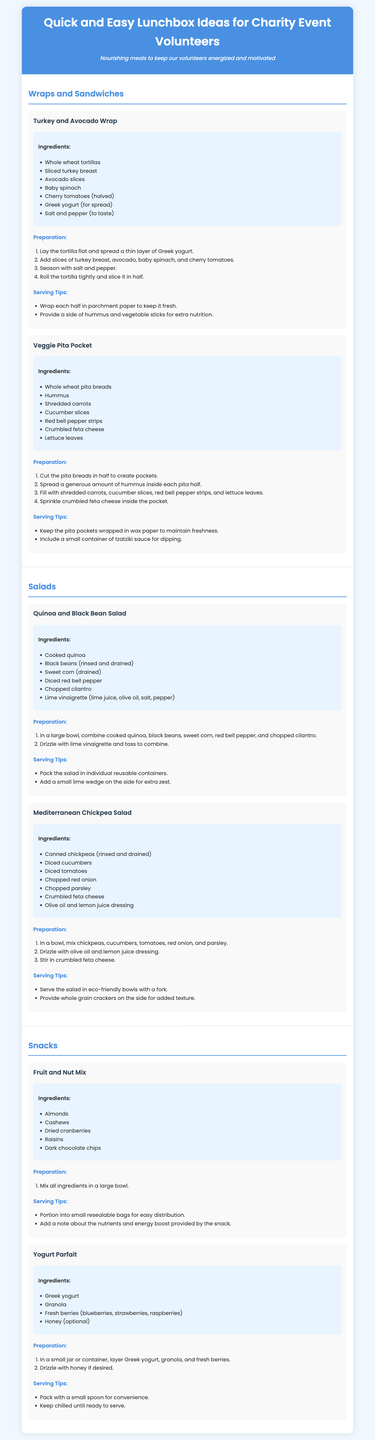What is the title of the document? The title of the document is mentioned in the header of the rendered document.
Answer: Quick and Easy Lunchbox Ideas for Charity Event Volunteers How many wraps or sandwiches are included in the document? The document contains a section titled "Wraps and Sandwiches" which lists two recipes.
Answer: 2 What is the primary ingredient in the Veggie Pita Pocket? The primary ingredient is specified in the list of ingredients for the Veggie Pita Pocket recipe.
Answer: Hummus What type of dressing is used in the Mediterranean Chickpea Salad? The type of dressing is described in the list of ingredients for the Mediterranean Chickpea Salad.
Answer: Olive oil and lemon juice What can be served with the Fruit and Nut Mix? The document suggests an additional item to be included with the snack in its serving tips.
Answer: A note about the nutrients and energy boost How is the Turkey and Avocado Wrap prepared? The preparation steps for the Turkey and Avocado Wrap recipe outline the actions taken to make the wrap.
Answer: Roll the tortilla tightly and slice it in half What is one suggested serving tip for the Quinoa and Black Bean Salad? The serving tips provide a suggestion on how to package the salad for serving.
Answer: Pack the salad in individual reusable containers Which ingredient adds sweetness to the Yogurt Parfait? The ingredients for the Yogurt Parfait include an optional sweetening ingredient.
Answer: Honey What is a suggested side for the Turkey and Avocado Wrap? The document contains a serving tips section that suggests an additional item to pair with the wrap.
Answer: Hummus and vegetable sticks 